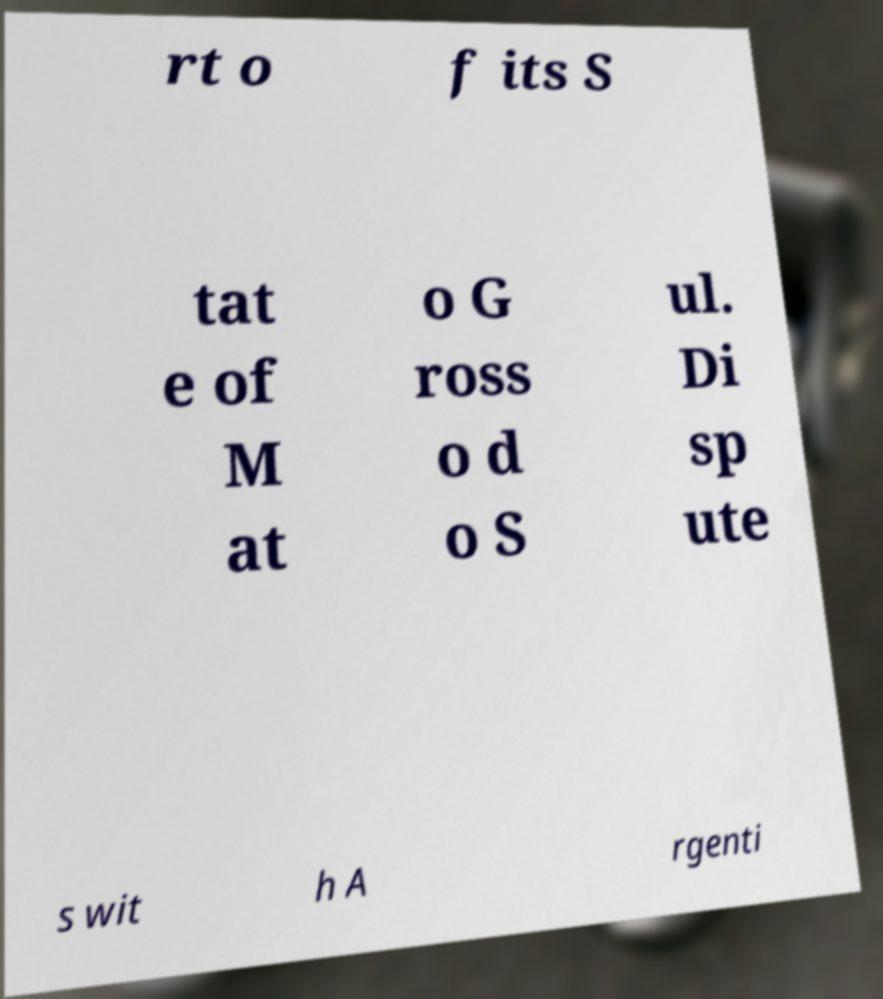There's text embedded in this image that I need extracted. Can you transcribe it verbatim? rt o f its S tat e of M at o G ross o d o S ul. Di sp ute s wit h A rgenti 